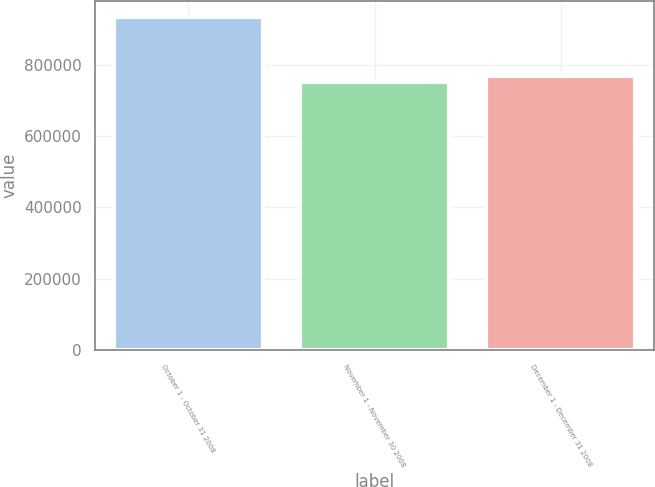Convert chart to OTSL. <chart><loc_0><loc_0><loc_500><loc_500><bar_chart><fcel>October 1 - October 31 2008<fcel>November 1 - November 30 2008<fcel>December 1 - December 31 2008<nl><fcel>933354<fcel>751468<fcel>769657<nl></chart> 